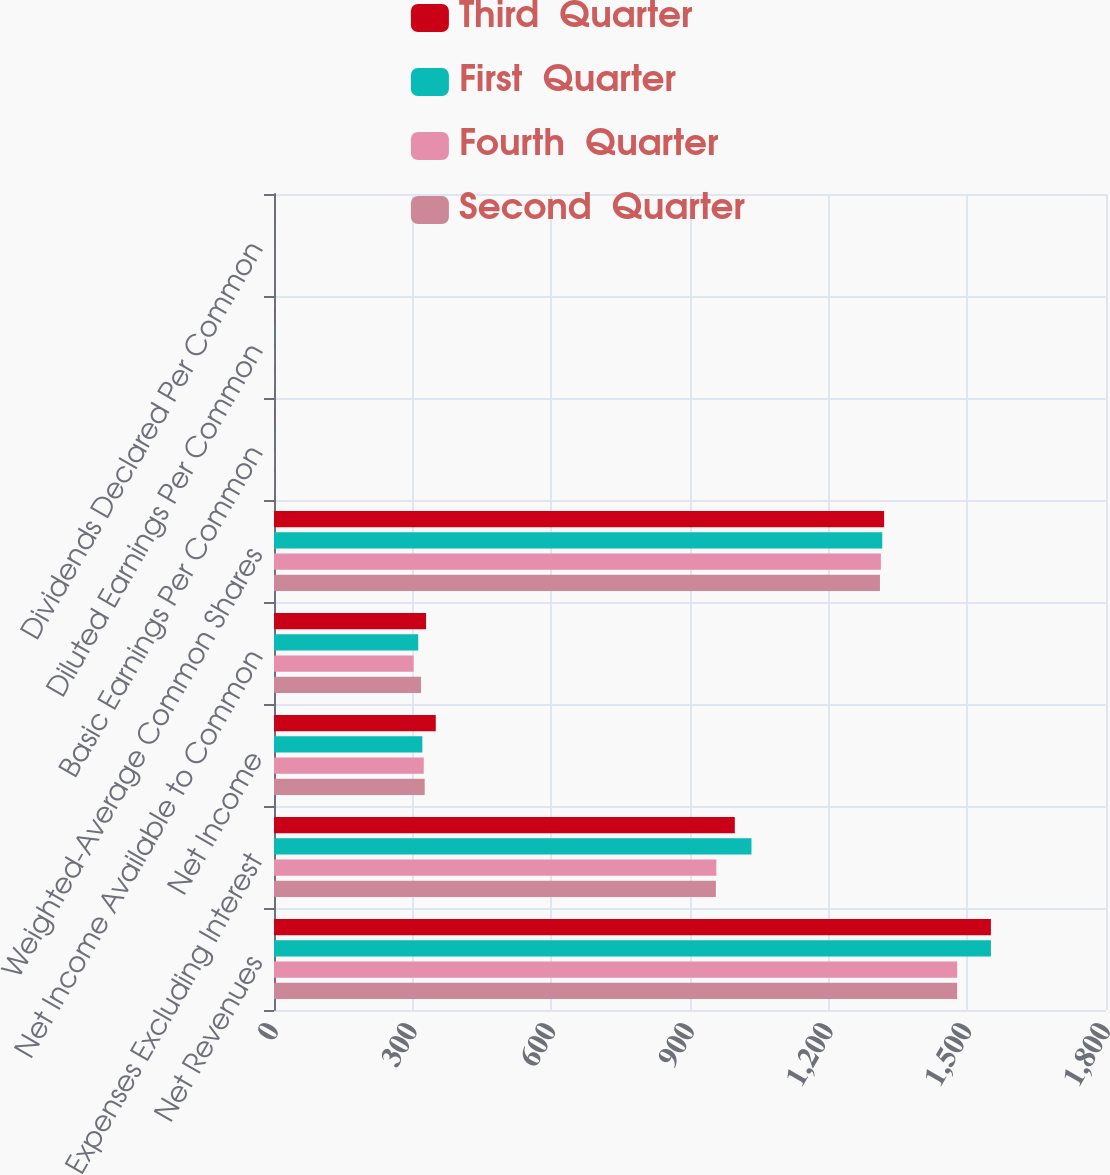Convert chart to OTSL. <chart><loc_0><loc_0><loc_500><loc_500><stacked_bar_chart><ecel><fcel>Net Revenues<fcel>Expenses Excluding Interest<fcel>Net Income<fcel>Net Income Available to Common<fcel>Weighted-Average Common Shares<fcel>Basic Earnings Per Common<fcel>Diluted Earnings Per Common<fcel>Dividends Declared Per Common<nl><fcel>Third  Quarter<fcel>1551<fcel>997<fcel>350<fcel>329<fcel>1320<fcel>0.25<fcel>0.25<fcel>0.06<nl><fcel>First  Quarter<fcel>1551<fcel>1033<fcel>321<fcel>312<fcel>1316<fcel>0.24<fcel>0.24<fcel>0.06<nl><fcel>Fourth  Quarter<fcel>1478<fcel>957<fcel>324<fcel>302<fcel>1313<fcel>0.23<fcel>0.23<fcel>0.06<nl><fcel>Second  Quarter<fcel>1478<fcel>956<fcel>326<fcel>318<fcel>1311<fcel>0.24<fcel>0.24<fcel>0.06<nl></chart> 